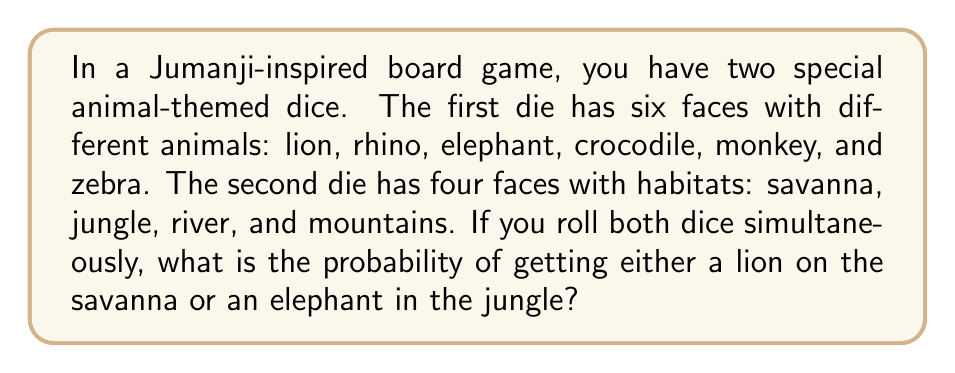Solve this math problem. Let's approach this step-by-step:

1) First, we need to identify the favorable outcomes:
   - Lion on savanna
   - Elephant in jungle

2) Now, let's calculate the probability of each favorable outcome:

   a) Probability of getting a lion on the savanna:
      - Probability of rolling a lion: $\frac{1}{6}$
      - Probability of rolling savanna: $\frac{1}{4}$
      - Probability of both occurring: $\frac{1}{6} \times \frac{1}{4} = \frac{1}{24}$

   b) Probability of getting an elephant in the jungle:
      - Probability of rolling an elephant: $\frac{1}{6}$
      - Probability of rolling jungle: $\frac{1}{4}$
      - Probability of both occurring: $\frac{1}{6} \times \frac{1}{4} = \frac{1}{24}$

3) Since we want the probability of either of these outcomes occurring, and they are mutually exclusive (cannot happen at the same time), we add their individual probabilities:

   $$P(\text{lion on savanna or elephant in jungle}) = \frac{1}{24} + \frac{1}{24} = \frac{2}{24} = \frac{1}{12}$$

Therefore, the probability of rolling either a lion on the savanna or an elephant in the jungle is $\frac{1}{12}$.
Answer: $\frac{1}{12}$ 